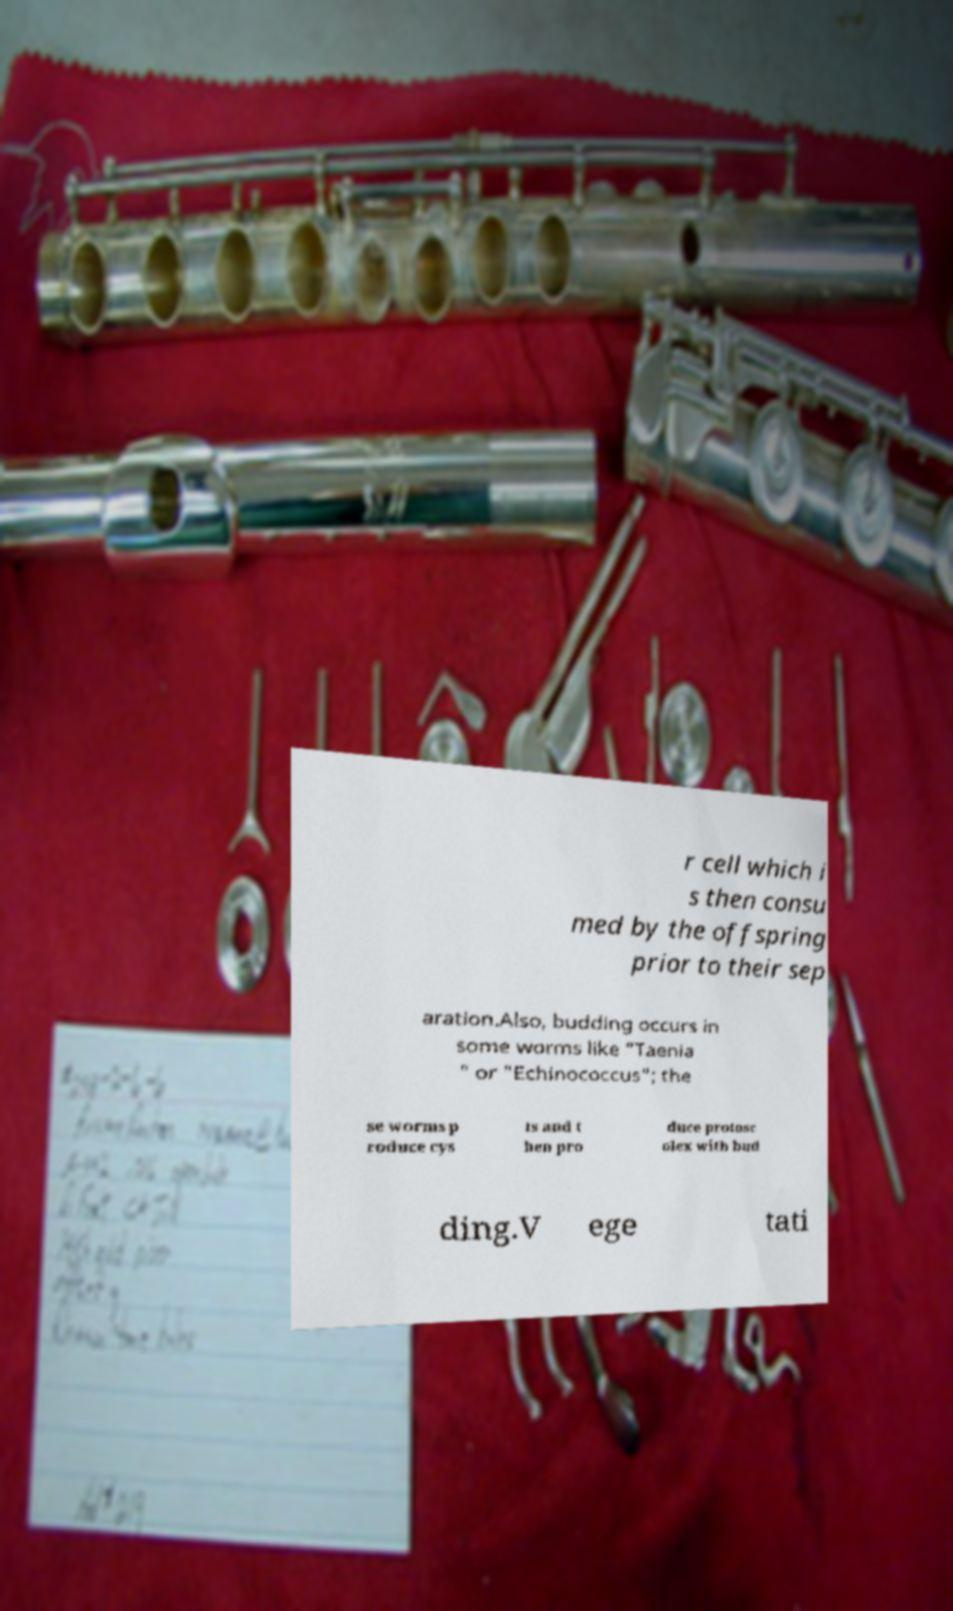Could you assist in decoding the text presented in this image and type it out clearly? r cell which i s then consu med by the offspring prior to their sep aration.Also, budding occurs in some worms like "Taenia " or "Echinococcus"; the se worms p roduce cys ts and t hen pro duce protosc olex with bud ding.V ege tati 